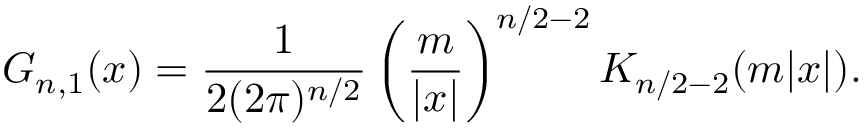Convert formula to latex. <formula><loc_0><loc_0><loc_500><loc_500>G _ { n , 1 } ( x ) = { \frac { 1 } { 2 ( 2 \pi ) ^ { n / 2 } } } \left ( { \frac { m } { | x | } } \right ) ^ { n / 2 - 2 } K _ { n / 2 - 2 } ( m | x | ) .</formula> 